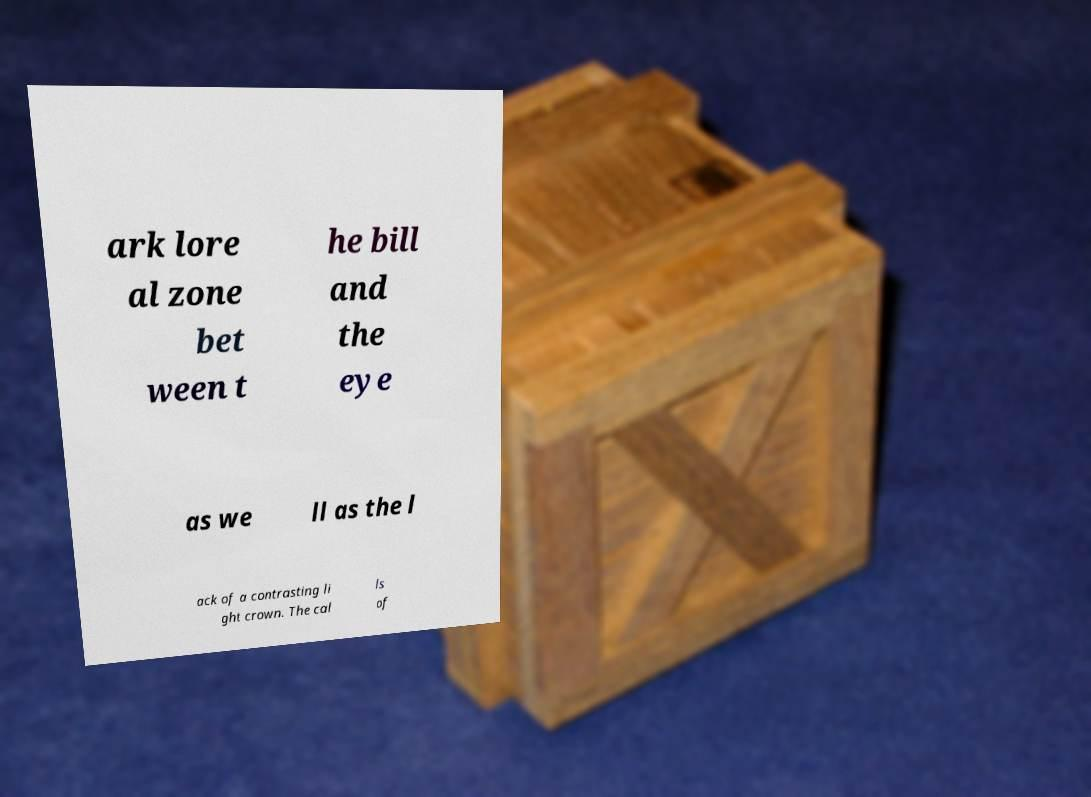Could you assist in decoding the text presented in this image and type it out clearly? ark lore al zone bet ween t he bill and the eye as we ll as the l ack of a contrasting li ght crown. The cal ls of 